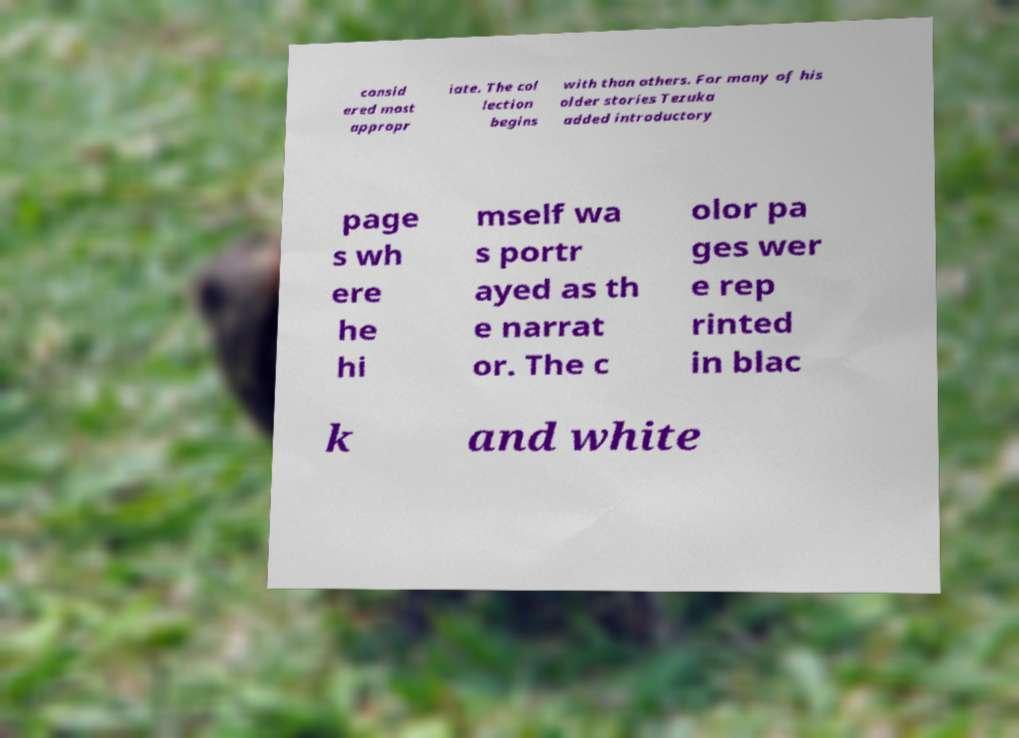Could you assist in decoding the text presented in this image and type it out clearly? consid ered most appropr iate. The col lection begins with than others. For many of his older stories Tezuka added introductory page s wh ere he hi mself wa s portr ayed as th e narrat or. The c olor pa ges wer e rep rinted in blac k and white 